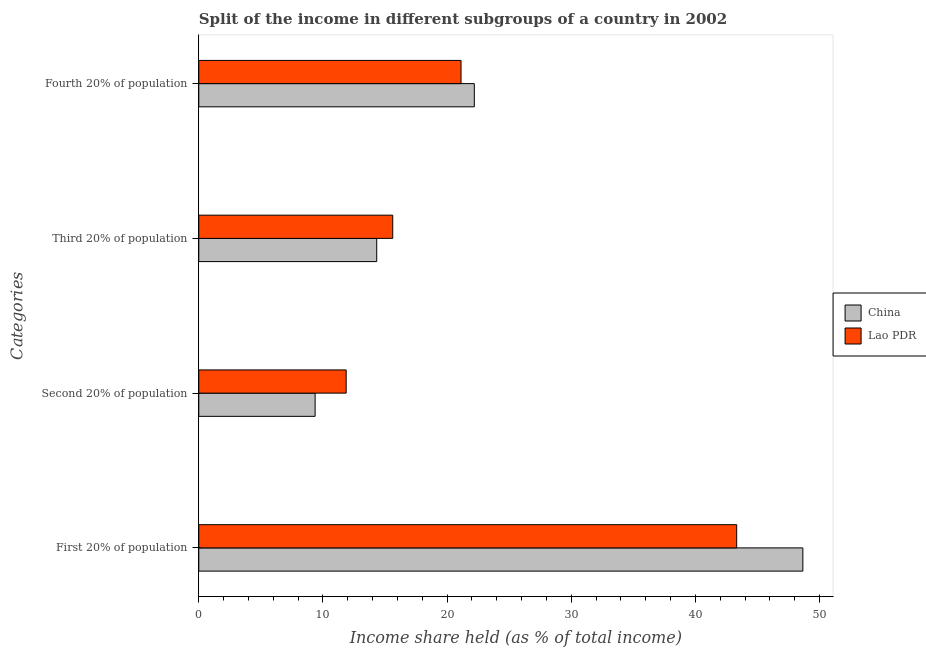How many groups of bars are there?
Your response must be concise. 4. Are the number of bars per tick equal to the number of legend labels?
Provide a short and direct response. Yes. Are the number of bars on each tick of the Y-axis equal?
Ensure brevity in your answer.  Yes. How many bars are there on the 4th tick from the top?
Provide a short and direct response. 2. What is the label of the 3rd group of bars from the top?
Make the answer very short. Second 20% of population. What is the share of the income held by first 20% of the population in China?
Give a very brief answer. 48.65. Across all countries, what is the maximum share of the income held by first 20% of the population?
Provide a short and direct response. 48.65. Across all countries, what is the minimum share of the income held by fourth 20% of the population?
Keep it short and to the point. 21.12. In which country was the share of the income held by first 20% of the population maximum?
Offer a terse response. China. What is the total share of the income held by fourth 20% of the population in the graph?
Give a very brief answer. 43.31. What is the difference between the share of the income held by third 20% of the population in China and that in Lao PDR?
Your answer should be compact. -1.29. What is the difference between the share of the income held by fourth 20% of the population in China and the share of the income held by third 20% of the population in Lao PDR?
Provide a short and direct response. 6.57. What is the average share of the income held by first 20% of the population per country?
Your response must be concise. 45.98. What is the difference between the share of the income held by fourth 20% of the population and share of the income held by third 20% of the population in China?
Ensure brevity in your answer.  7.86. What is the ratio of the share of the income held by fourth 20% of the population in China to that in Lao PDR?
Give a very brief answer. 1.05. What is the difference between the highest and the second highest share of the income held by second 20% of the population?
Your answer should be compact. 2.5. What is the difference between the highest and the lowest share of the income held by first 20% of the population?
Keep it short and to the point. 5.33. Is it the case that in every country, the sum of the share of the income held by fourth 20% of the population and share of the income held by third 20% of the population is greater than the sum of share of the income held by first 20% of the population and share of the income held by second 20% of the population?
Offer a terse response. No. What does the 2nd bar from the top in Third 20% of population represents?
Give a very brief answer. China. What does the 2nd bar from the bottom in First 20% of population represents?
Provide a succinct answer. Lao PDR. How many bars are there?
Provide a succinct answer. 8. Are all the bars in the graph horizontal?
Your answer should be very brief. Yes. How many countries are there in the graph?
Offer a very short reply. 2. Are the values on the major ticks of X-axis written in scientific E-notation?
Make the answer very short. No. Does the graph contain any zero values?
Provide a succinct answer. No. Does the graph contain grids?
Offer a terse response. No. Where does the legend appear in the graph?
Your response must be concise. Center right. How many legend labels are there?
Provide a succinct answer. 2. What is the title of the graph?
Offer a terse response. Split of the income in different subgroups of a country in 2002. Does "Timor-Leste" appear as one of the legend labels in the graph?
Offer a terse response. No. What is the label or title of the X-axis?
Your answer should be very brief. Income share held (as % of total income). What is the label or title of the Y-axis?
Your response must be concise. Categories. What is the Income share held (as % of total income) in China in First 20% of population?
Provide a succinct answer. 48.65. What is the Income share held (as % of total income) in Lao PDR in First 20% of population?
Keep it short and to the point. 43.32. What is the Income share held (as % of total income) in China in Second 20% of population?
Offer a very short reply. 9.37. What is the Income share held (as % of total income) of Lao PDR in Second 20% of population?
Your answer should be very brief. 11.87. What is the Income share held (as % of total income) of China in Third 20% of population?
Your answer should be compact. 14.33. What is the Income share held (as % of total income) of Lao PDR in Third 20% of population?
Your response must be concise. 15.62. What is the Income share held (as % of total income) of China in Fourth 20% of population?
Your response must be concise. 22.19. What is the Income share held (as % of total income) in Lao PDR in Fourth 20% of population?
Your answer should be very brief. 21.12. Across all Categories, what is the maximum Income share held (as % of total income) of China?
Make the answer very short. 48.65. Across all Categories, what is the maximum Income share held (as % of total income) of Lao PDR?
Provide a succinct answer. 43.32. Across all Categories, what is the minimum Income share held (as % of total income) in China?
Your answer should be compact. 9.37. Across all Categories, what is the minimum Income share held (as % of total income) of Lao PDR?
Make the answer very short. 11.87. What is the total Income share held (as % of total income) in China in the graph?
Offer a terse response. 94.54. What is the total Income share held (as % of total income) in Lao PDR in the graph?
Your answer should be compact. 91.93. What is the difference between the Income share held (as % of total income) in China in First 20% of population and that in Second 20% of population?
Give a very brief answer. 39.28. What is the difference between the Income share held (as % of total income) of Lao PDR in First 20% of population and that in Second 20% of population?
Your answer should be compact. 31.45. What is the difference between the Income share held (as % of total income) of China in First 20% of population and that in Third 20% of population?
Offer a terse response. 34.32. What is the difference between the Income share held (as % of total income) in Lao PDR in First 20% of population and that in Third 20% of population?
Keep it short and to the point. 27.7. What is the difference between the Income share held (as % of total income) in China in First 20% of population and that in Fourth 20% of population?
Your response must be concise. 26.46. What is the difference between the Income share held (as % of total income) in China in Second 20% of population and that in Third 20% of population?
Your answer should be compact. -4.96. What is the difference between the Income share held (as % of total income) of Lao PDR in Second 20% of population and that in Third 20% of population?
Give a very brief answer. -3.75. What is the difference between the Income share held (as % of total income) of China in Second 20% of population and that in Fourth 20% of population?
Your answer should be very brief. -12.82. What is the difference between the Income share held (as % of total income) in Lao PDR in Second 20% of population and that in Fourth 20% of population?
Make the answer very short. -9.25. What is the difference between the Income share held (as % of total income) in China in Third 20% of population and that in Fourth 20% of population?
Provide a succinct answer. -7.86. What is the difference between the Income share held (as % of total income) of Lao PDR in Third 20% of population and that in Fourth 20% of population?
Provide a short and direct response. -5.5. What is the difference between the Income share held (as % of total income) of China in First 20% of population and the Income share held (as % of total income) of Lao PDR in Second 20% of population?
Your answer should be compact. 36.78. What is the difference between the Income share held (as % of total income) in China in First 20% of population and the Income share held (as % of total income) in Lao PDR in Third 20% of population?
Make the answer very short. 33.03. What is the difference between the Income share held (as % of total income) in China in First 20% of population and the Income share held (as % of total income) in Lao PDR in Fourth 20% of population?
Provide a short and direct response. 27.53. What is the difference between the Income share held (as % of total income) of China in Second 20% of population and the Income share held (as % of total income) of Lao PDR in Third 20% of population?
Your response must be concise. -6.25. What is the difference between the Income share held (as % of total income) of China in Second 20% of population and the Income share held (as % of total income) of Lao PDR in Fourth 20% of population?
Provide a succinct answer. -11.75. What is the difference between the Income share held (as % of total income) of China in Third 20% of population and the Income share held (as % of total income) of Lao PDR in Fourth 20% of population?
Your response must be concise. -6.79. What is the average Income share held (as % of total income) in China per Categories?
Provide a short and direct response. 23.64. What is the average Income share held (as % of total income) of Lao PDR per Categories?
Give a very brief answer. 22.98. What is the difference between the Income share held (as % of total income) in China and Income share held (as % of total income) in Lao PDR in First 20% of population?
Ensure brevity in your answer.  5.33. What is the difference between the Income share held (as % of total income) in China and Income share held (as % of total income) in Lao PDR in Third 20% of population?
Ensure brevity in your answer.  -1.29. What is the difference between the Income share held (as % of total income) of China and Income share held (as % of total income) of Lao PDR in Fourth 20% of population?
Provide a short and direct response. 1.07. What is the ratio of the Income share held (as % of total income) of China in First 20% of population to that in Second 20% of population?
Keep it short and to the point. 5.19. What is the ratio of the Income share held (as % of total income) in Lao PDR in First 20% of population to that in Second 20% of population?
Your answer should be very brief. 3.65. What is the ratio of the Income share held (as % of total income) in China in First 20% of population to that in Third 20% of population?
Your response must be concise. 3.4. What is the ratio of the Income share held (as % of total income) of Lao PDR in First 20% of population to that in Third 20% of population?
Offer a very short reply. 2.77. What is the ratio of the Income share held (as % of total income) in China in First 20% of population to that in Fourth 20% of population?
Ensure brevity in your answer.  2.19. What is the ratio of the Income share held (as % of total income) of Lao PDR in First 20% of population to that in Fourth 20% of population?
Provide a short and direct response. 2.05. What is the ratio of the Income share held (as % of total income) of China in Second 20% of population to that in Third 20% of population?
Your answer should be compact. 0.65. What is the ratio of the Income share held (as % of total income) in Lao PDR in Second 20% of population to that in Third 20% of population?
Provide a succinct answer. 0.76. What is the ratio of the Income share held (as % of total income) in China in Second 20% of population to that in Fourth 20% of population?
Offer a terse response. 0.42. What is the ratio of the Income share held (as % of total income) of Lao PDR in Second 20% of population to that in Fourth 20% of population?
Give a very brief answer. 0.56. What is the ratio of the Income share held (as % of total income) of China in Third 20% of population to that in Fourth 20% of population?
Keep it short and to the point. 0.65. What is the ratio of the Income share held (as % of total income) of Lao PDR in Third 20% of population to that in Fourth 20% of population?
Provide a succinct answer. 0.74. What is the difference between the highest and the second highest Income share held (as % of total income) of China?
Give a very brief answer. 26.46. What is the difference between the highest and the second highest Income share held (as % of total income) of Lao PDR?
Your answer should be very brief. 22.2. What is the difference between the highest and the lowest Income share held (as % of total income) in China?
Give a very brief answer. 39.28. What is the difference between the highest and the lowest Income share held (as % of total income) of Lao PDR?
Offer a terse response. 31.45. 